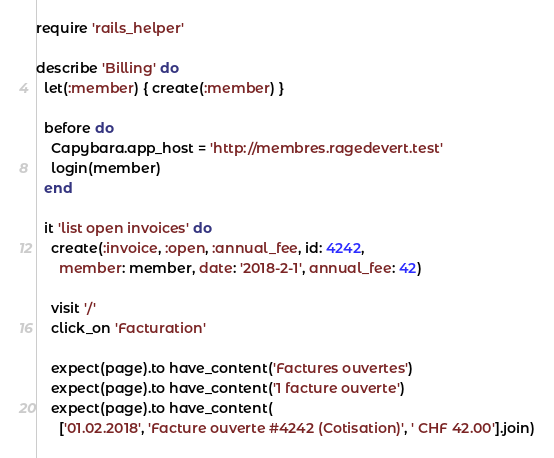Convert code to text. <code><loc_0><loc_0><loc_500><loc_500><_Ruby_>require 'rails_helper'

describe 'Billing' do
  let(:member) { create(:member) }

  before do
    Capybara.app_host = 'http://membres.ragedevert.test'
    login(member)
  end

  it 'list open invoices' do
    create(:invoice, :open, :annual_fee, id: 4242,
      member: member, date: '2018-2-1', annual_fee: 42)

    visit '/'
    click_on 'Facturation'

    expect(page).to have_content('Factures ouvertes')
    expect(page).to have_content('1 facture ouverte')
    expect(page).to have_content(
      ['01.02.2018', 'Facture ouverte #4242 (Cotisation)', ' CHF 42.00'].join)</code> 